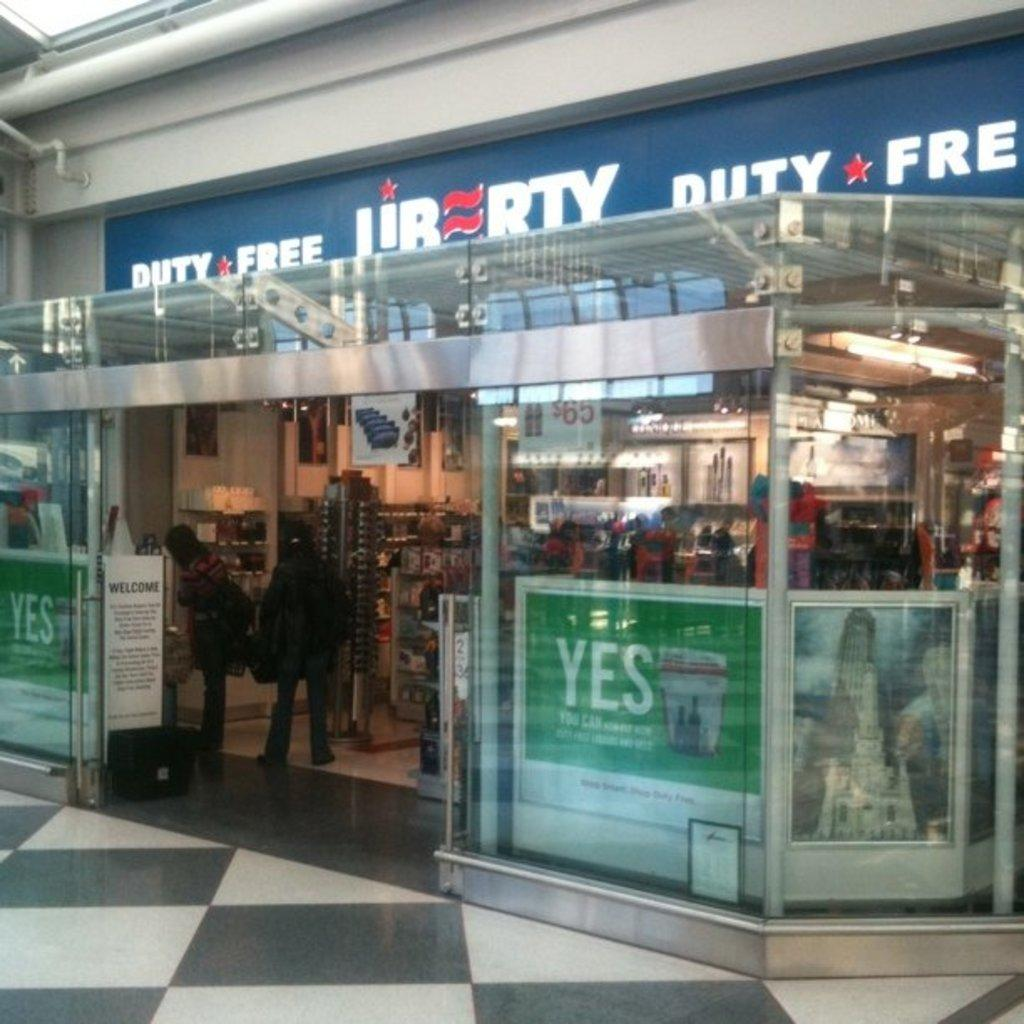Provide a one-sentence caption for the provided image. The blue sign says Duty Free on the top of it. 